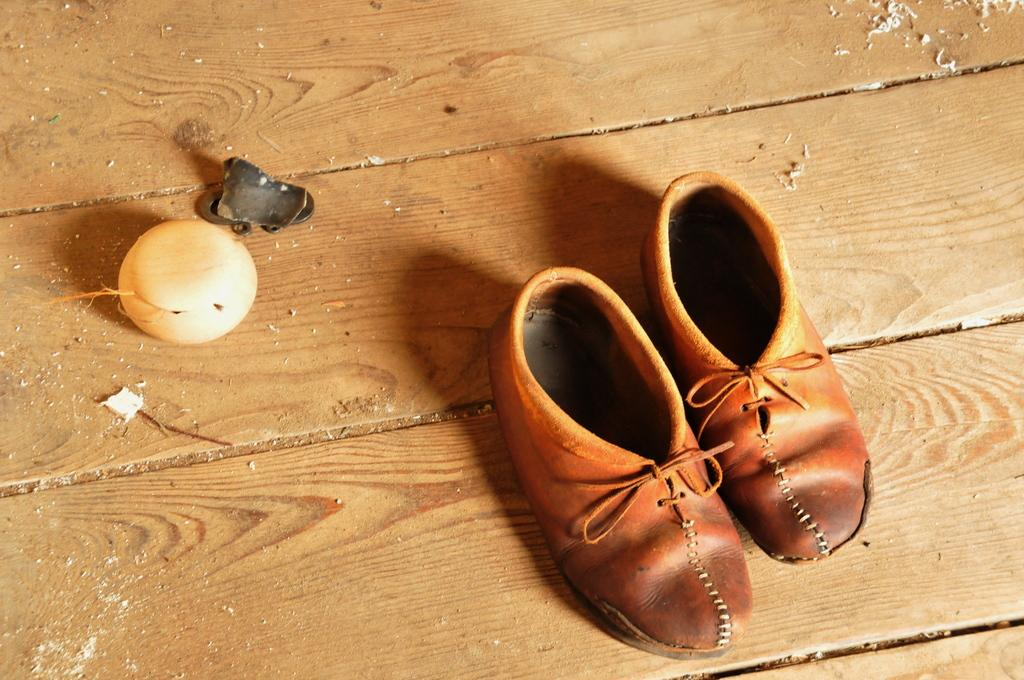What type of footwear is visible in the image? There is a pair of shoes in the image. What other object can be seen in the image? There is a ball in the image. What material is the metal object made of? The metal object in the image is made of metal. On what surface are the objects placed? The objects are on a wooden platform. Can you tell me how many owls are sitting on the ball in the image? There are no owls present in the image; it only features a pair of shoes, a ball, and a metal object on a wooden platform. 